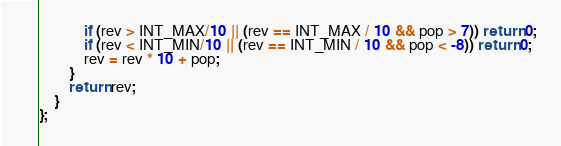<code> <loc_0><loc_0><loc_500><loc_500><_C++_>            if (rev > INT_MAX/10 || (rev == INT_MAX / 10 && pop > 7)) return 0;
            if (rev < INT_MIN/10 || (rev == INT_MIN / 10 && pop < -8)) return 0;
            rev = rev * 10 + pop;
        }
        return rev;
    }
};
</code> 